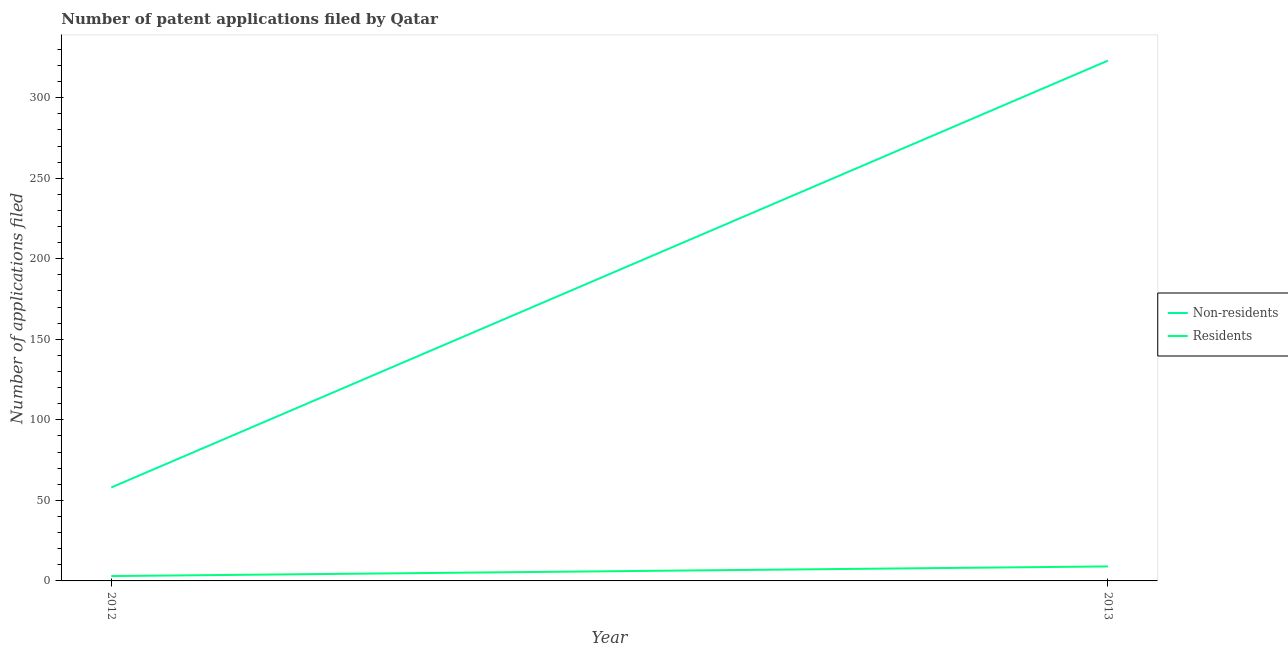How many different coloured lines are there?
Give a very brief answer. 2. Does the line corresponding to number of patent applications by residents intersect with the line corresponding to number of patent applications by non residents?
Offer a terse response. No. What is the number of patent applications by non residents in 2013?
Offer a terse response. 323. Across all years, what is the maximum number of patent applications by residents?
Ensure brevity in your answer.  9. Across all years, what is the minimum number of patent applications by residents?
Give a very brief answer. 3. In which year was the number of patent applications by non residents maximum?
Your response must be concise. 2013. What is the total number of patent applications by non residents in the graph?
Provide a short and direct response. 381. What is the difference between the number of patent applications by non residents in 2012 and that in 2013?
Keep it short and to the point. -265. What is the difference between the number of patent applications by non residents in 2013 and the number of patent applications by residents in 2012?
Offer a very short reply. 320. What is the average number of patent applications by residents per year?
Your response must be concise. 6. In the year 2012, what is the difference between the number of patent applications by residents and number of patent applications by non residents?
Your answer should be compact. -55. In how many years, is the number of patent applications by residents greater than 50?
Your response must be concise. 0. What is the ratio of the number of patent applications by residents in 2012 to that in 2013?
Your answer should be compact. 0.33. Is the number of patent applications by residents in 2012 less than that in 2013?
Provide a succinct answer. Yes. Does the number of patent applications by residents monotonically increase over the years?
Your answer should be very brief. Yes. How many lines are there?
Offer a terse response. 2. Does the graph contain grids?
Your answer should be compact. No. How are the legend labels stacked?
Give a very brief answer. Vertical. What is the title of the graph?
Provide a short and direct response. Number of patent applications filed by Qatar. Does "Working capital" appear as one of the legend labels in the graph?
Your answer should be very brief. No. What is the label or title of the X-axis?
Make the answer very short. Year. What is the label or title of the Y-axis?
Ensure brevity in your answer.  Number of applications filed. What is the Number of applications filed of Residents in 2012?
Offer a terse response. 3. What is the Number of applications filed in Non-residents in 2013?
Offer a terse response. 323. Across all years, what is the maximum Number of applications filed in Non-residents?
Make the answer very short. 323. Across all years, what is the minimum Number of applications filed of Non-residents?
Provide a succinct answer. 58. Across all years, what is the minimum Number of applications filed of Residents?
Your answer should be very brief. 3. What is the total Number of applications filed of Non-residents in the graph?
Ensure brevity in your answer.  381. What is the total Number of applications filed in Residents in the graph?
Offer a very short reply. 12. What is the difference between the Number of applications filed of Non-residents in 2012 and that in 2013?
Provide a short and direct response. -265. What is the difference between the Number of applications filed of Non-residents in 2012 and the Number of applications filed of Residents in 2013?
Your response must be concise. 49. What is the average Number of applications filed of Non-residents per year?
Offer a very short reply. 190.5. What is the average Number of applications filed in Residents per year?
Your response must be concise. 6. In the year 2012, what is the difference between the Number of applications filed of Non-residents and Number of applications filed of Residents?
Ensure brevity in your answer.  55. In the year 2013, what is the difference between the Number of applications filed in Non-residents and Number of applications filed in Residents?
Provide a succinct answer. 314. What is the ratio of the Number of applications filed of Non-residents in 2012 to that in 2013?
Your answer should be very brief. 0.18. What is the difference between the highest and the second highest Number of applications filed of Non-residents?
Provide a short and direct response. 265. What is the difference between the highest and the lowest Number of applications filed in Non-residents?
Offer a terse response. 265. 